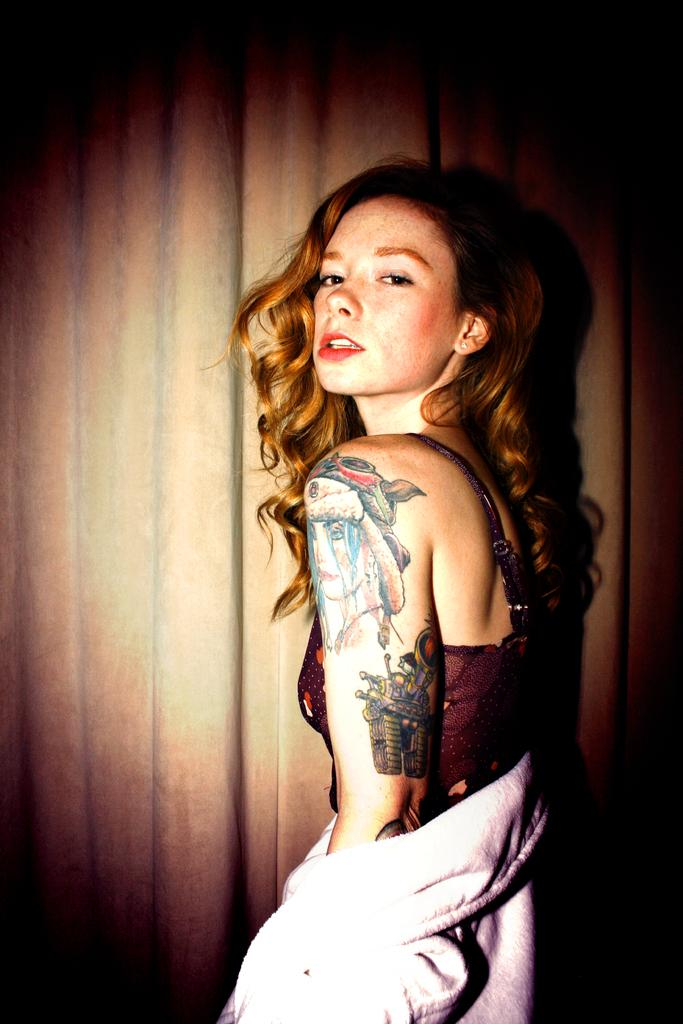What is the main subject of the image? There is a person standing in the image. What is the person wearing? The person is wearing a white dress. What color is the background of the image? The background of the image is brown in color. What type of nerve can be seen in the image? There is no nerve present in the image; it features a person standing in a brown background. 